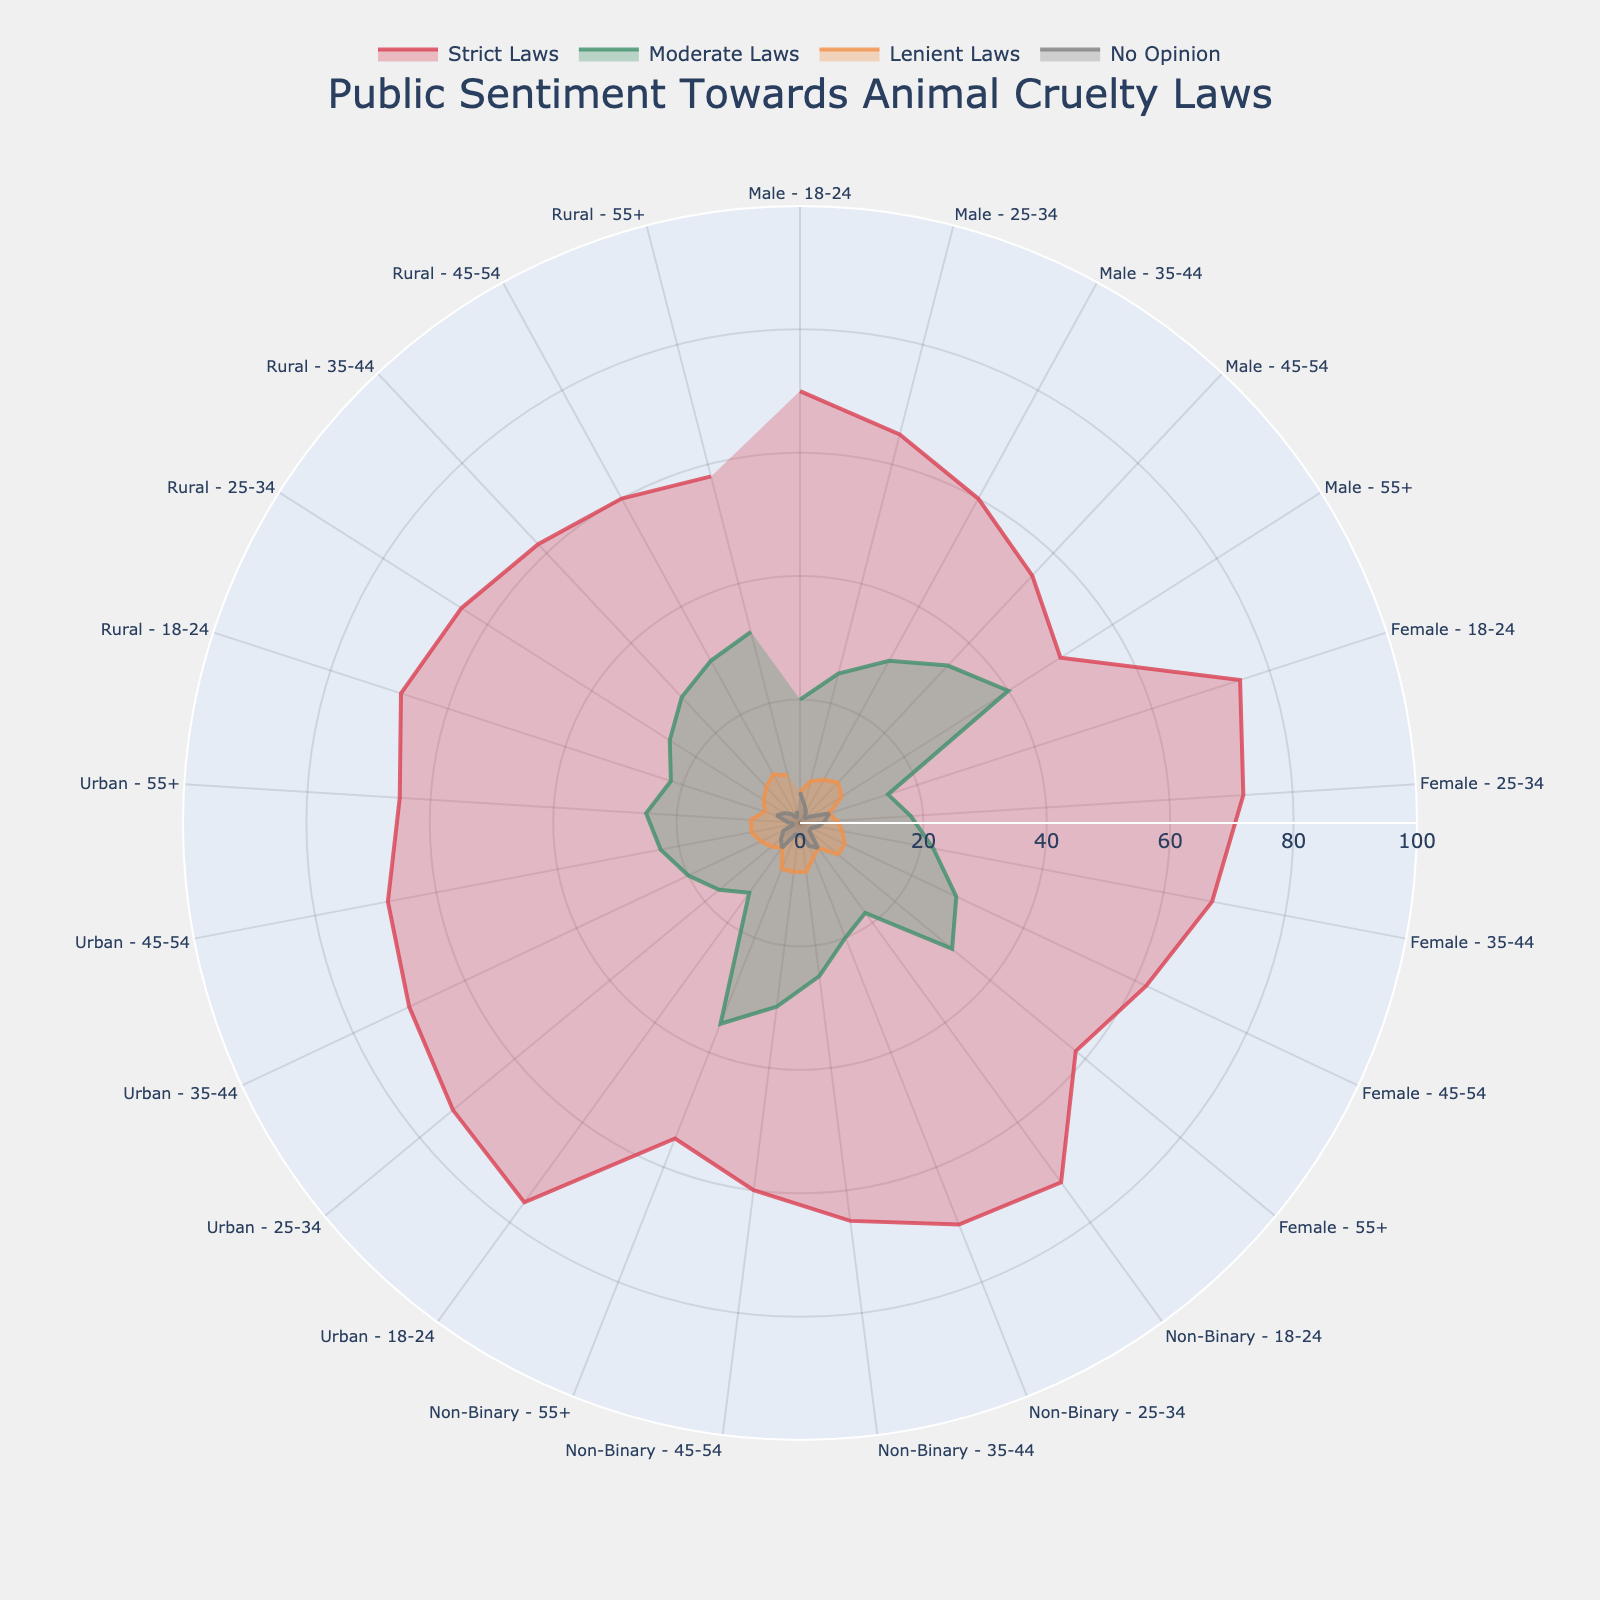What's the title of the figure? The title is usually placed at the top of the figure. Reading it shows that it currently displays the public sentiment regarding animal cruelty laws.
Answer: Public Sentiment Towards Animal Cruelty Laws Which demographic group has the highest support for strict laws against animal cruelty among young adults aged 18-24? By visually comparing the lengths of the radial sections for strict laws among 18-24 age groups, see that the "Urban - 18-24" group has the longest radial section for strict laws.
Answer: Urban - 18-24 What's the difference in support for strict laws against animal cruelty between males aged 55+ and females aged 55+? Find the corresponding lengths for strict laws for both demographics. For males aged 55+, it's 50%, and for females aged 55+, it's 58%. Subtract these two values.
Answer: 8% Which demographic group shows the highest "No Opinion" on laws against animal cruelty? Locate the longest radial section for the "No Opinion" category. The longest radial section is found in the "Female - 25-34" group.
Answer: Female - 25-34 Compare the support for moderate laws against animal cruelty between rural and urban residents aged 35-44. Which group has a higher value? Check the lengths for moderate laws for both demographics in the 35-44 age group. "Urban - 35-44" has 20%, and "Rural - 35-44" has 28%. Therefore, rural residents have a higher value.
Answer: Rural - 35-44 What's the average support for strict laws against animal cruelty for all age groups and demographics? Add up all percentage values for strict laws across all demographics and age groups and then divide by the number of groups. Sum is (70+65+60+55+50+75+72+68+62+58+72+70+65+60+55+76+73+70+68+65+68+65+62+60+58), which equals 1609. Since there are 25 groups, the average is 1609/25.
Answer: 64.36% Which demographic shows the highest support for lenient laws against animal cruelty? Identify the longest radial section for lenient laws. The "Male - 45-54" demographic, has the highest value at 9%.
Answer: Male - 45-54 What is the sum of percentages for support for all types of laws (strict, moderate, lenient, no opinion) for non-binary individuals aged 18-24? Add the percentages for non-binary individuals aged 18-24 across all categories (72 + 18 + 5 + 5). The sum is 100.
Answer: 100% Which demographic group's support for moderate laws is exactly double its support for lenient laws? Check for a demographic where the moderate laws percentage is exactly twice that of lenient laws. For example, for "Male - 18-24" it's 20% for moderate and 5% for lenient, which fits this relationship.
Answer: Male - 18-24 